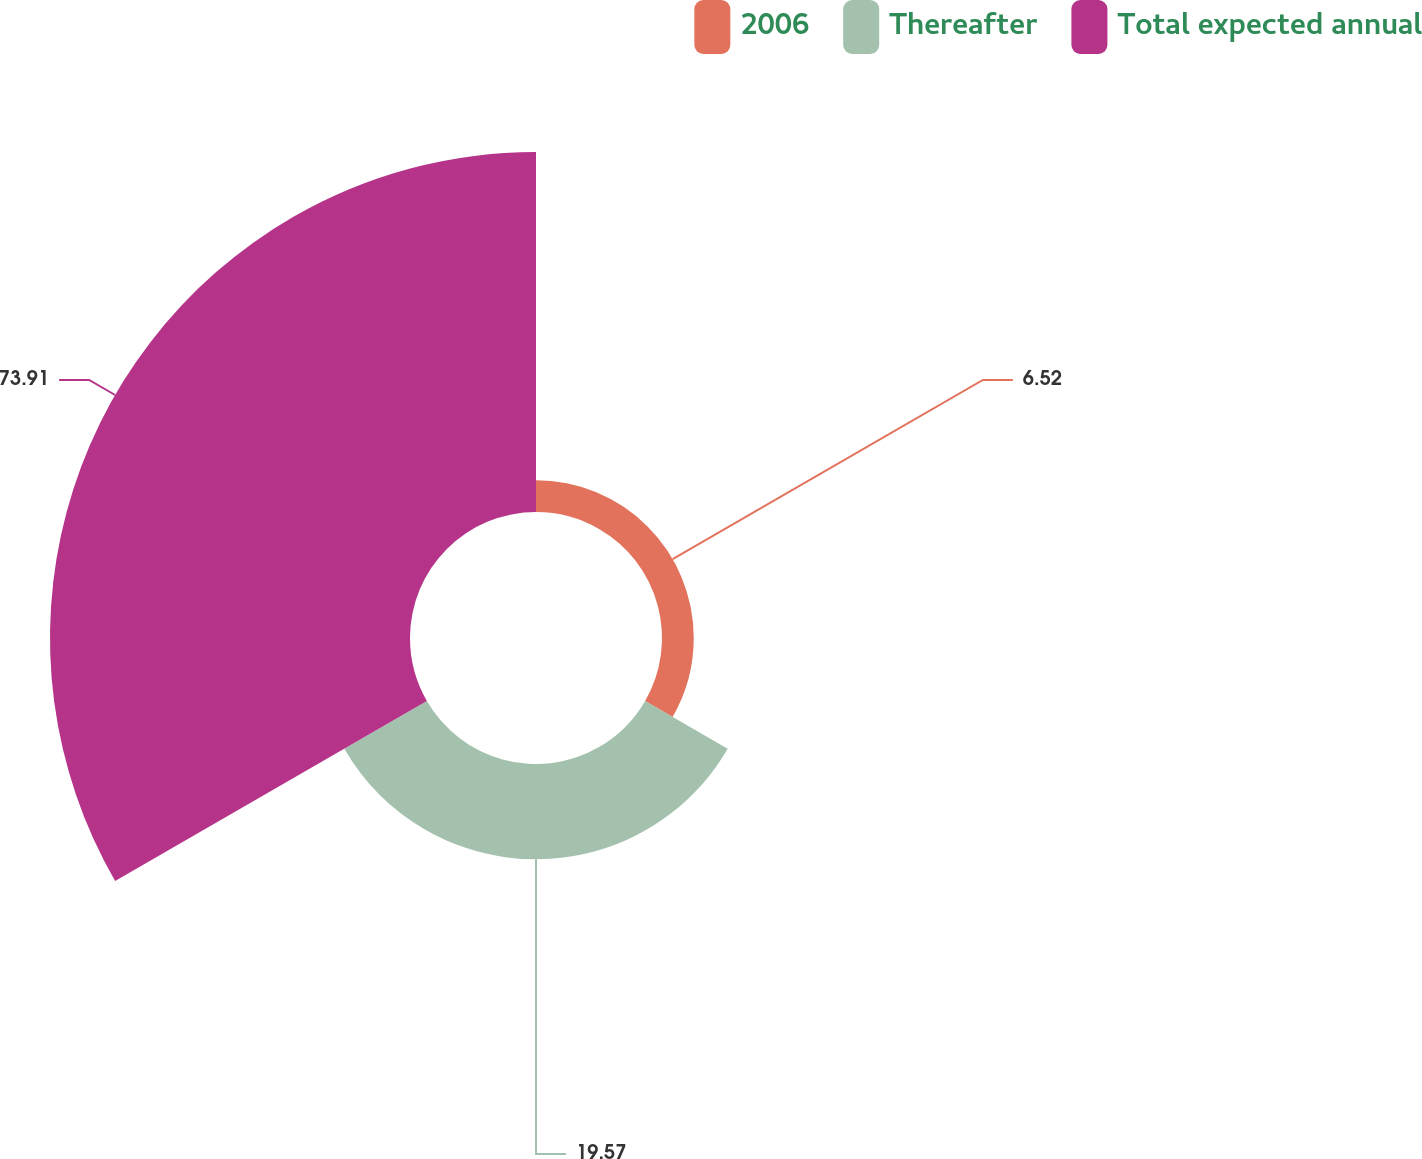Convert chart to OTSL. <chart><loc_0><loc_0><loc_500><loc_500><pie_chart><fcel>2006<fcel>Thereafter<fcel>Total expected annual<nl><fcel>6.52%<fcel>19.57%<fcel>73.91%<nl></chart> 